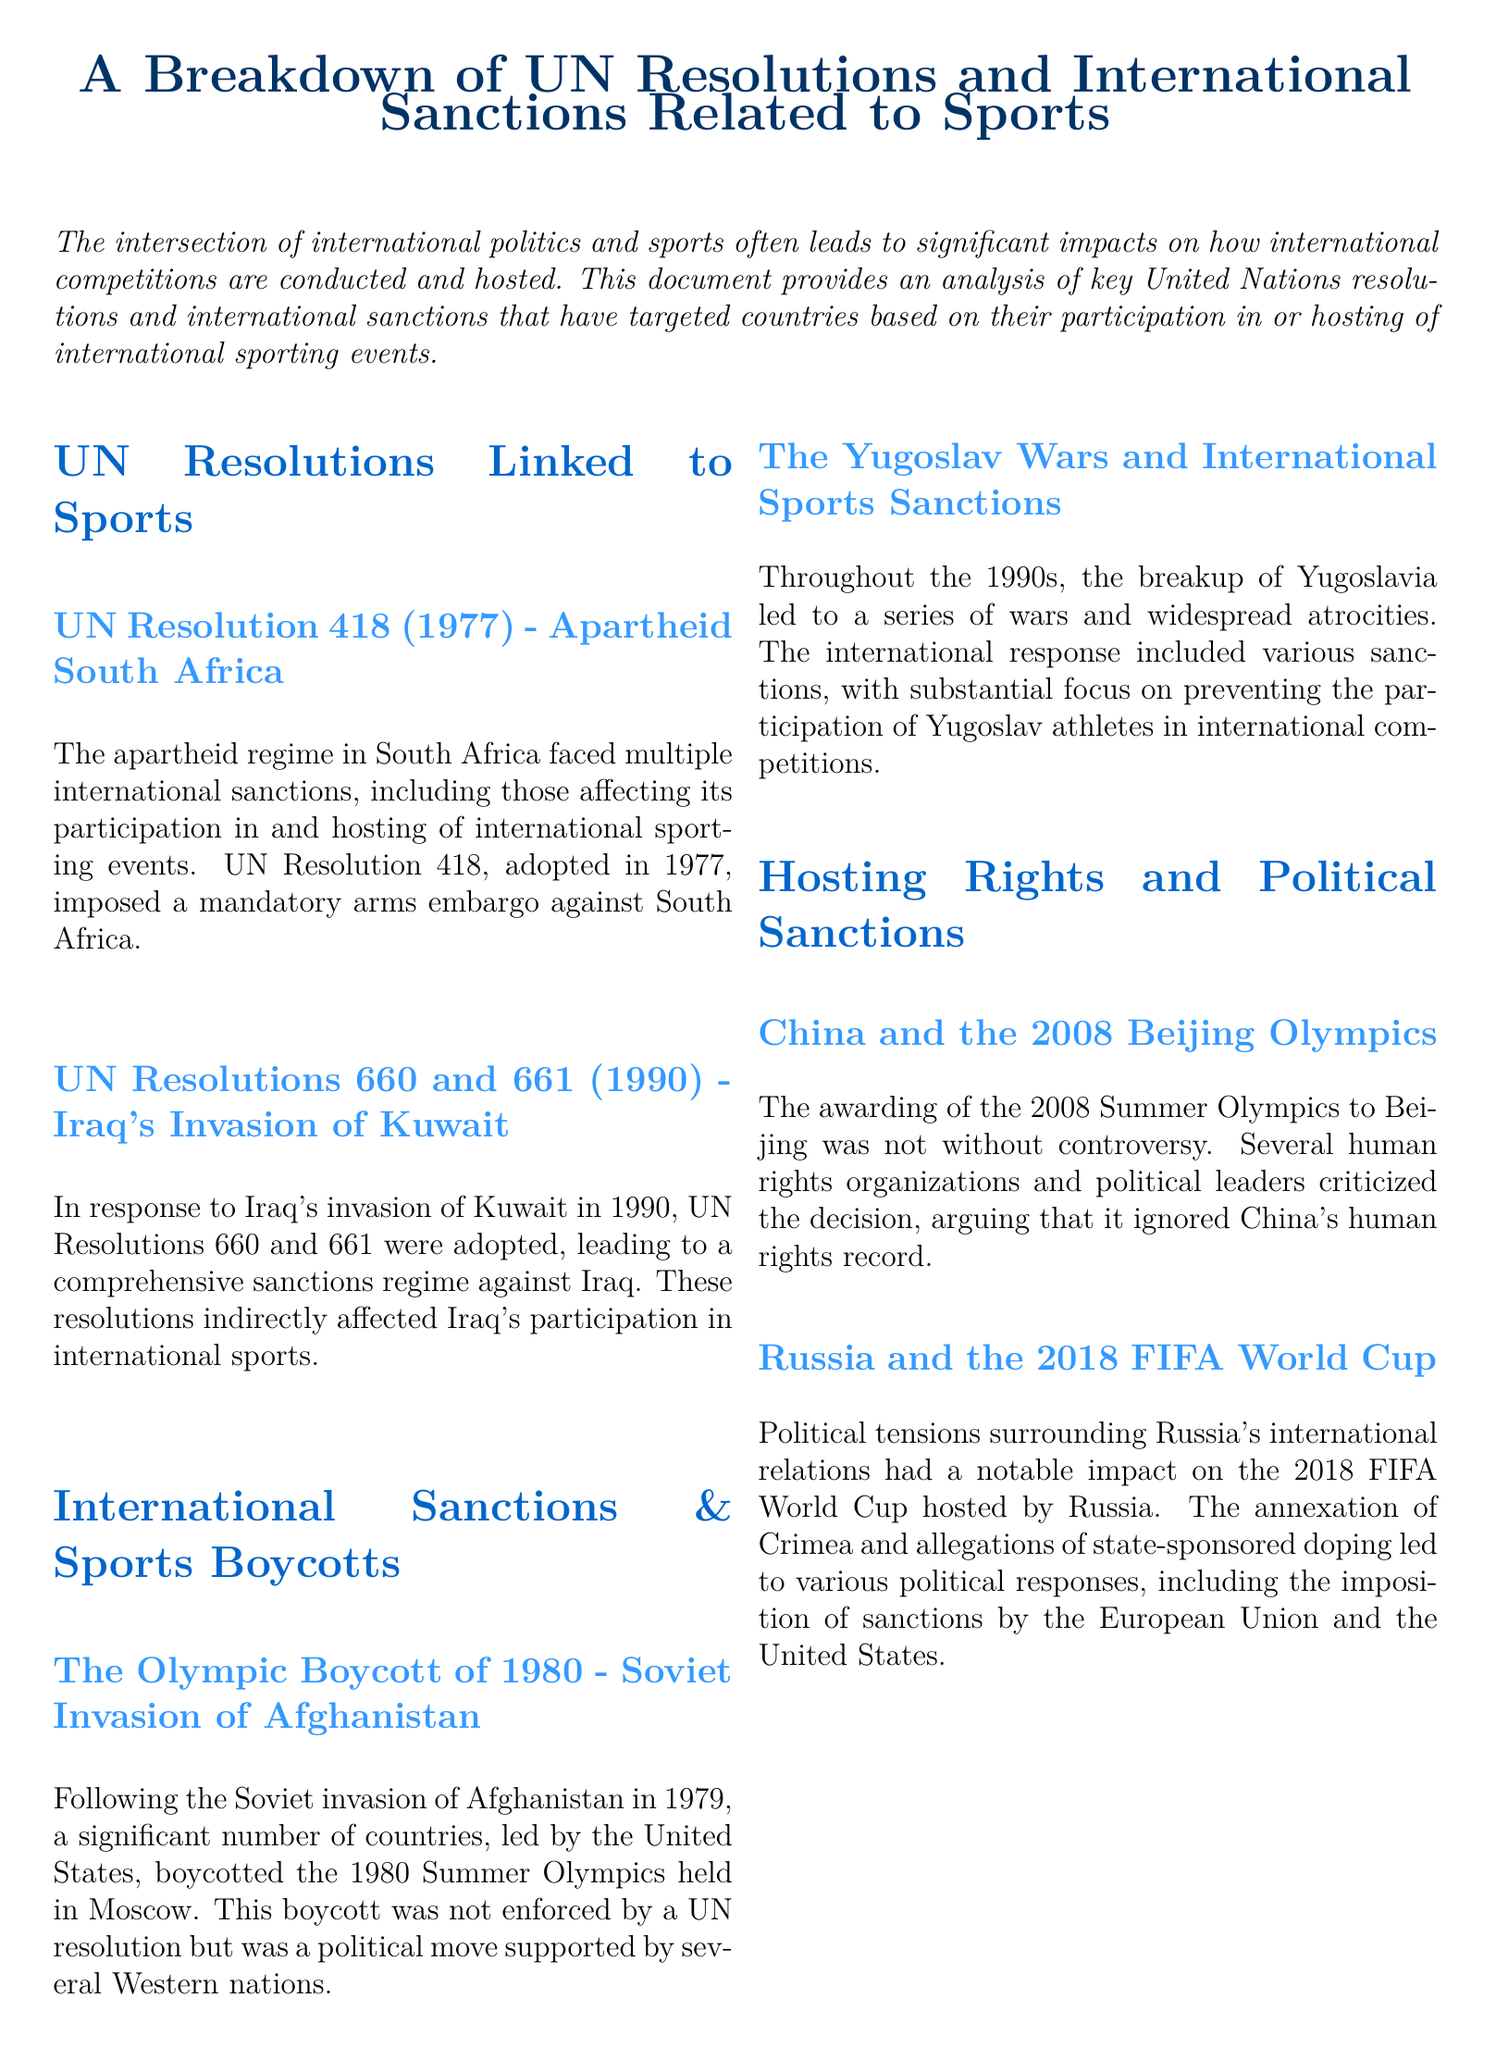What is the title of the document? The title of the document is presented at the top of the first page.
Answer: A Breakdown of UN Resolutions and International Sanctions Related to Sports Which UN resolution was adopted in 1977? The resolution is stated under the section discussing apartheid South Africa.
Answer: UN Resolution 418 What event led to the Olympic Boycott of 1980? The document provides a specific historical event linked to the boycott.
Answer: Soviet Invasion of Afghanistan Which country hosted the 2018 FIFA World Cup? The hosting country is mentioned in the section about political sanctions.
Answer: Russia What were the UN Resolutions adopted in 1990 in response to Iraq? The document lists these resolutions that imposed sanctions on Iraq.
Answer: 660 and 661 What action was imposed on South Africa during its apartheid regime? The specific type of sanction against South Africa is highlighted in the document.
Answer: Mandatory arms embargo Which international event did the international response focus on in the 1990s regarding Yugoslavia? The focus of the sanctions is identified in the context of Yugoslav athletes.
Answer: International competitions What criticism was directed at China's hosting of the 2008 Olympics? The document states the reason for the criticism concerning the event.
Answer: Human rights record Which two entities imposed sanctions in response to Russia's actions? The entities are listed in relation to the political situation and the World Cup.
Answer: European Union and United States 